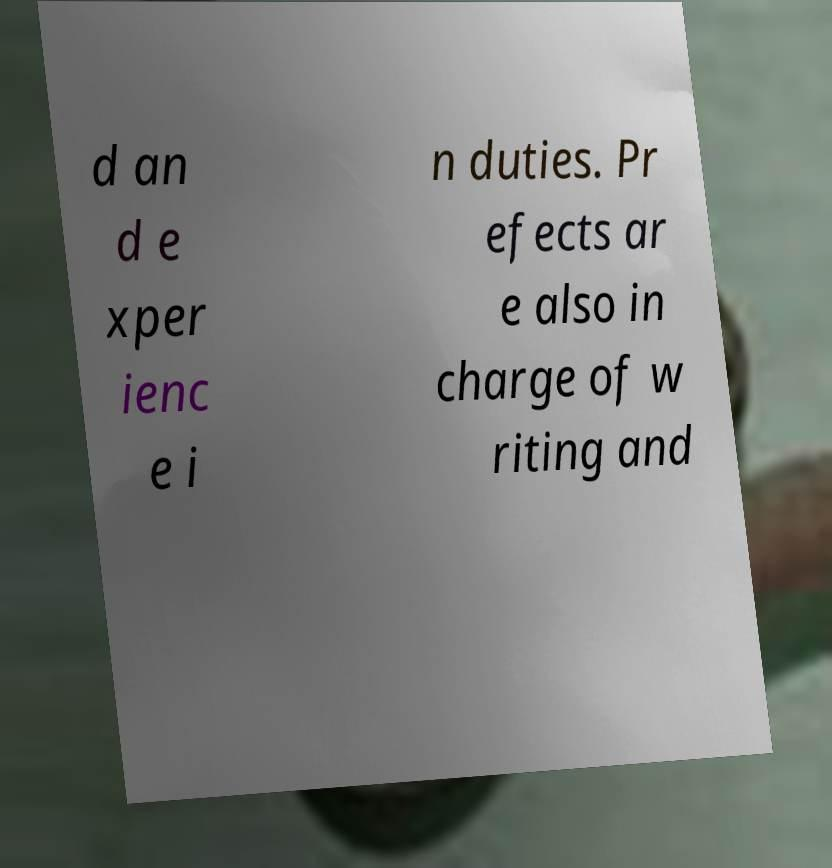Could you extract and type out the text from this image? d an d e xper ienc e i n duties. Pr efects ar e also in charge of w riting and 